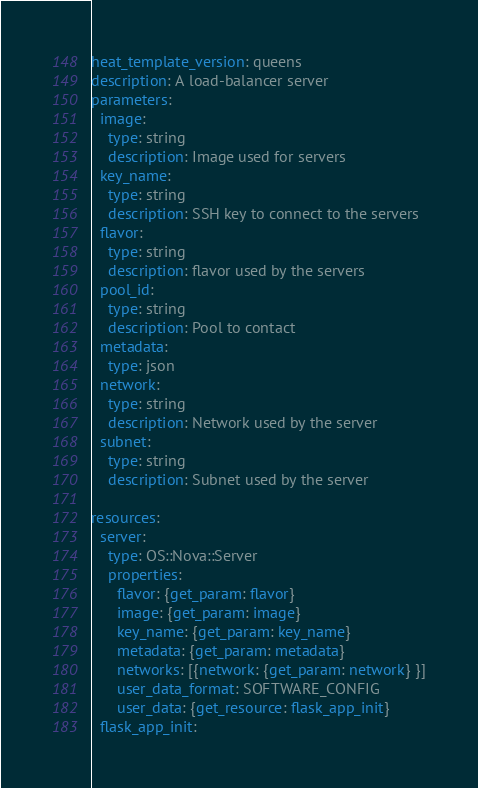<code> <loc_0><loc_0><loc_500><loc_500><_YAML_>heat_template_version: queens
description: A load-balancer server
parameters:
  image:
    type: string
    description: Image used for servers
  key_name:
    type: string
    description: SSH key to connect to the servers
  flavor:
    type: string
    description: flavor used by the servers
  pool_id:
    type: string
    description: Pool to contact
  metadata:
    type: json
  network:
    type: string
    description: Network used by the server
  subnet:
    type: string
    description: Subnet used by the server

resources:
  server:
    type: OS::Nova::Server
    properties:
      flavor: {get_param: flavor}
      image: {get_param: image}
      key_name: {get_param: key_name}
      metadata: {get_param: metadata}
      networks: [{network: {get_param: network} }]
      user_data_format: SOFTWARE_CONFIG
      user_data: {get_resource: flask_app_init}
  flask_app_init:</code> 